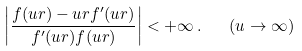<formula> <loc_0><loc_0><loc_500><loc_500>\left | \frac { f ( u r ) - u r f ^ { \prime } ( u r ) } { f ^ { \prime } ( u r ) f ( u r ) } \right | < + \infty \, . \quad ( u \to \infty )</formula> 